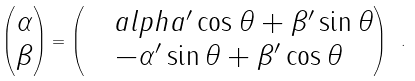Convert formula to latex. <formula><loc_0><loc_0><loc_500><loc_500>\begin{pmatrix} \alpha \\ \beta \\ \end{pmatrix} = \begin{pmatrix} \quad a l p h a ^ { \prime } \cos \theta + \beta ^ { \prime } \sin \theta \\ - \alpha ^ { \prime } \sin \theta + \beta ^ { \prime } \cos \theta \\ \end{pmatrix} \ .</formula> 